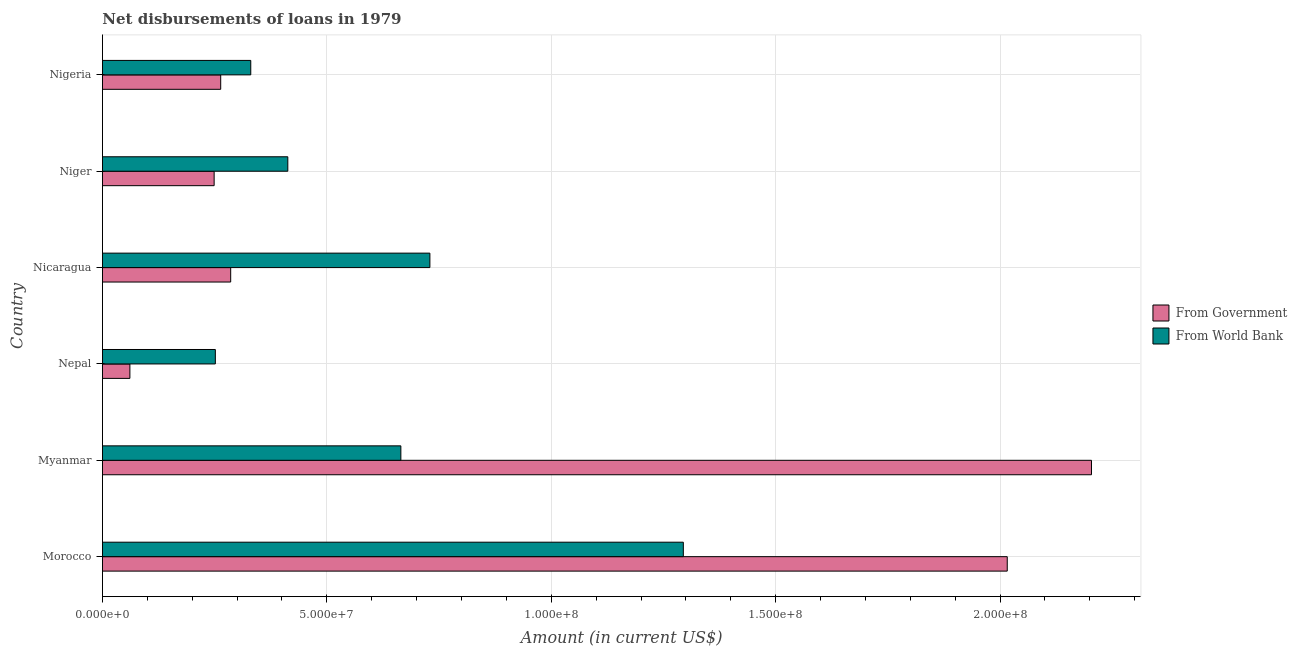How many different coloured bars are there?
Your response must be concise. 2. How many groups of bars are there?
Give a very brief answer. 6. How many bars are there on the 6th tick from the bottom?
Make the answer very short. 2. What is the label of the 3rd group of bars from the top?
Ensure brevity in your answer.  Nicaragua. In how many cases, is the number of bars for a given country not equal to the number of legend labels?
Give a very brief answer. 0. What is the net disbursements of loan from world bank in Niger?
Your response must be concise. 4.13e+07. Across all countries, what is the maximum net disbursements of loan from world bank?
Provide a short and direct response. 1.29e+08. Across all countries, what is the minimum net disbursements of loan from government?
Your answer should be compact. 6.11e+06. In which country was the net disbursements of loan from world bank maximum?
Ensure brevity in your answer.  Morocco. In which country was the net disbursements of loan from government minimum?
Offer a terse response. Nepal. What is the total net disbursements of loan from government in the graph?
Your answer should be very brief. 5.08e+08. What is the difference between the net disbursements of loan from world bank in Morocco and that in Myanmar?
Keep it short and to the point. 6.29e+07. What is the difference between the net disbursements of loan from world bank in Morocco and the net disbursements of loan from government in Nepal?
Offer a terse response. 1.23e+08. What is the average net disbursements of loan from world bank per country?
Provide a succinct answer. 6.14e+07. What is the difference between the net disbursements of loan from world bank and net disbursements of loan from government in Nepal?
Your answer should be very brief. 1.90e+07. What is the ratio of the net disbursements of loan from world bank in Nepal to that in Niger?
Your answer should be very brief. 0.61. Is the difference between the net disbursements of loan from government in Morocco and Nepal greater than the difference between the net disbursements of loan from world bank in Morocco and Nepal?
Make the answer very short. Yes. What is the difference between the highest and the second highest net disbursements of loan from government?
Make the answer very short. 1.88e+07. What is the difference between the highest and the lowest net disbursements of loan from government?
Keep it short and to the point. 2.14e+08. In how many countries, is the net disbursements of loan from world bank greater than the average net disbursements of loan from world bank taken over all countries?
Provide a short and direct response. 3. What does the 1st bar from the top in Morocco represents?
Offer a very short reply. From World Bank. What does the 1st bar from the bottom in Nepal represents?
Make the answer very short. From Government. What is the difference between two consecutive major ticks on the X-axis?
Give a very brief answer. 5.00e+07. What is the title of the graph?
Make the answer very short. Net disbursements of loans in 1979. Does "Age 15+" appear as one of the legend labels in the graph?
Offer a very short reply. No. What is the label or title of the X-axis?
Make the answer very short. Amount (in current US$). What is the label or title of the Y-axis?
Offer a very short reply. Country. What is the Amount (in current US$) of From Government in Morocco?
Provide a short and direct response. 2.02e+08. What is the Amount (in current US$) in From World Bank in Morocco?
Offer a very short reply. 1.29e+08. What is the Amount (in current US$) in From Government in Myanmar?
Provide a succinct answer. 2.20e+08. What is the Amount (in current US$) in From World Bank in Myanmar?
Your response must be concise. 6.65e+07. What is the Amount (in current US$) in From Government in Nepal?
Make the answer very short. 6.11e+06. What is the Amount (in current US$) of From World Bank in Nepal?
Offer a terse response. 2.52e+07. What is the Amount (in current US$) in From Government in Nicaragua?
Provide a short and direct response. 2.86e+07. What is the Amount (in current US$) in From World Bank in Nicaragua?
Offer a terse response. 7.30e+07. What is the Amount (in current US$) of From Government in Niger?
Provide a short and direct response. 2.49e+07. What is the Amount (in current US$) in From World Bank in Niger?
Your answer should be very brief. 4.13e+07. What is the Amount (in current US$) of From Government in Nigeria?
Your answer should be very brief. 2.63e+07. What is the Amount (in current US$) in From World Bank in Nigeria?
Your answer should be very brief. 3.30e+07. Across all countries, what is the maximum Amount (in current US$) in From Government?
Your answer should be compact. 2.20e+08. Across all countries, what is the maximum Amount (in current US$) of From World Bank?
Keep it short and to the point. 1.29e+08. Across all countries, what is the minimum Amount (in current US$) of From Government?
Make the answer very short. 6.11e+06. Across all countries, what is the minimum Amount (in current US$) in From World Bank?
Your response must be concise. 2.52e+07. What is the total Amount (in current US$) in From Government in the graph?
Offer a terse response. 5.08e+08. What is the total Amount (in current US$) of From World Bank in the graph?
Keep it short and to the point. 3.68e+08. What is the difference between the Amount (in current US$) of From Government in Morocco and that in Myanmar?
Keep it short and to the point. -1.88e+07. What is the difference between the Amount (in current US$) in From World Bank in Morocco and that in Myanmar?
Offer a very short reply. 6.29e+07. What is the difference between the Amount (in current US$) of From Government in Morocco and that in Nepal?
Provide a succinct answer. 1.95e+08. What is the difference between the Amount (in current US$) of From World Bank in Morocco and that in Nepal?
Your answer should be very brief. 1.04e+08. What is the difference between the Amount (in current US$) in From Government in Morocco and that in Nicaragua?
Make the answer very short. 1.73e+08. What is the difference between the Amount (in current US$) in From World Bank in Morocco and that in Nicaragua?
Your answer should be compact. 5.65e+07. What is the difference between the Amount (in current US$) of From Government in Morocco and that in Niger?
Keep it short and to the point. 1.77e+08. What is the difference between the Amount (in current US$) of From World Bank in Morocco and that in Niger?
Your response must be concise. 8.81e+07. What is the difference between the Amount (in current US$) in From Government in Morocco and that in Nigeria?
Keep it short and to the point. 1.75e+08. What is the difference between the Amount (in current US$) in From World Bank in Morocco and that in Nigeria?
Keep it short and to the point. 9.64e+07. What is the difference between the Amount (in current US$) in From Government in Myanmar and that in Nepal?
Offer a terse response. 2.14e+08. What is the difference between the Amount (in current US$) of From World Bank in Myanmar and that in Nepal?
Provide a short and direct response. 4.13e+07. What is the difference between the Amount (in current US$) in From Government in Myanmar and that in Nicaragua?
Offer a terse response. 1.92e+08. What is the difference between the Amount (in current US$) in From World Bank in Myanmar and that in Nicaragua?
Offer a terse response. -6.47e+06. What is the difference between the Amount (in current US$) in From Government in Myanmar and that in Niger?
Make the answer very short. 1.95e+08. What is the difference between the Amount (in current US$) of From World Bank in Myanmar and that in Niger?
Your response must be concise. 2.52e+07. What is the difference between the Amount (in current US$) of From Government in Myanmar and that in Nigeria?
Keep it short and to the point. 1.94e+08. What is the difference between the Amount (in current US$) in From World Bank in Myanmar and that in Nigeria?
Offer a very short reply. 3.34e+07. What is the difference between the Amount (in current US$) in From Government in Nepal and that in Nicaragua?
Ensure brevity in your answer.  -2.25e+07. What is the difference between the Amount (in current US$) of From World Bank in Nepal and that in Nicaragua?
Offer a very short reply. -4.78e+07. What is the difference between the Amount (in current US$) in From Government in Nepal and that in Niger?
Ensure brevity in your answer.  -1.88e+07. What is the difference between the Amount (in current US$) in From World Bank in Nepal and that in Niger?
Offer a very short reply. -1.61e+07. What is the difference between the Amount (in current US$) of From Government in Nepal and that in Nigeria?
Make the answer very short. -2.02e+07. What is the difference between the Amount (in current US$) in From World Bank in Nepal and that in Nigeria?
Offer a very short reply. -7.90e+06. What is the difference between the Amount (in current US$) of From Government in Nicaragua and that in Niger?
Make the answer very short. 3.69e+06. What is the difference between the Amount (in current US$) of From World Bank in Nicaragua and that in Niger?
Your response must be concise. 3.17e+07. What is the difference between the Amount (in current US$) of From Government in Nicaragua and that in Nigeria?
Your answer should be compact. 2.22e+06. What is the difference between the Amount (in current US$) in From World Bank in Nicaragua and that in Nigeria?
Your answer should be very brief. 3.99e+07. What is the difference between the Amount (in current US$) of From Government in Niger and that in Nigeria?
Your answer should be compact. -1.46e+06. What is the difference between the Amount (in current US$) of From World Bank in Niger and that in Nigeria?
Keep it short and to the point. 8.25e+06. What is the difference between the Amount (in current US$) of From Government in Morocco and the Amount (in current US$) of From World Bank in Myanmar?
Your answer should be compact. 1.35e+08. What is the difference between the Amount (in current US$) in From Government in Morocco and the Amount (in current US$) in From World Bank in Nepal?
Provide a short and direct response. 1.76e+08. What is the difference between the Amount (in current US$) in From Government in Morocco and the Amount (in current US$) in From World Bank in Nicaragua?
Your response must be concise. 1.29e+08. What is the difference between the Amount (in current US$) in From Government in Morocco and the Amount (in current US$) in From World Bank in Niger?
Make the answer very short. 1.60e+08. What is the difference between the Amount (in current US$) in From Government in Morocco and the Amount (in current US$) in From World Bank in Nigeria?
Make the answer very short. 1.69e+08. What is the difference between the Amount (in current US$) of From Government in Myanmar and the Amount (in current US$) of From World Bank in Nepal?
Provide a succinct answer. 1.95e+08. What is the difference between the Amount (in current US$) in From Government in Myanmar and the Amount (in current US$) in From World Bank in Nicaragua?
Provide a short and direct response. 1.47e+08. What is the difference between the Amount (in current US$) in From Government in Myanmar and the Amount (in current US$) in From World Bank in Niger?
Provide a short and direct response. 1.79e+08. What is the difference between the Amount (in current US$) in From Government in Myanmar and the Amount (in current US$) in From World Bank in Nigeria?
Provide a short and direct response. 1.87e+08. What is the difference between the Amount (in current US$) in From Government in Nepal and the Amount (in current US$) in From World Bank in Nicaragua?
Make the answer very short. -6.68e+07. What is the difference between the Amount (in current US$) of From Government in Nepal and the Amount (in current US$) of From World Bank in Niger?
Ensure brevity in your answer.  -3.52e+07. What is the difference between the Amount (in current US$) in From Government in Nepal and the Amount (in current US$) in From World Bank in Nigeria?
Offer a terse response. -2.69e+07. What is the difference between the Amount (in current US$) in From Government in Nicaragua and the Amount (in current US$) in From World Bank in Niger?
Offer a terse response. -1.27e+07. What is the difference between the Amount (in current US$) of From Government in Nicaragua and the Amount (in current US$) of From World Bank in Nigeria?
Your answer should be compact. -4.48e+06. What is the difference between the Amount (in current US$) of From Government in Niger and the Amount (in current US$) of From World Bank in Nigeria?
Offer a very short reply. -8.16e+06. What is the average Amount (in current US$) in From Government per country?
Provide a succinct answer. 8.46e+07. What is the average Amount (in current US$) of From World Bank per country?
Ensure brevity in your answer.  6.14e+07. What is the difference between the Amount (in current US$) in From Government and Amount (in current US$) in From World Bank in Morocco?
Ensure brevity in your answer.  7.22e+07. What is the difference between the Amount (in current US$) of From Government and Amount (in current US$) of From World Bank in Myanmar?
Your answer should be compact. 1.54e+08. What is the difference between the Amount (in current US$) in From Government and Amount (in current US$) in From World Bank in Nepal?
Offer a very short reply. -1.90e+07. What is the difference between the Amount (in current US$) of From Government and Amount (in current US$) of From World Bank in Nicaragua?
Your answer should be compact. -4.44e+07. What is the difference between the Amount (in current US$) of From Government and Amount (in current US$) of From World Bank in Niger?
Ensure brevity in your answer.  -1.64e+07. What is the difference between the Amount (in current US$) in From Government and Amount (in current US$) in From World Bank in Nigeria?
Your answer should be compact. -6.70e+06. What is the ratio of the Amount (in current US$) of From Government in Morocco to that in Myanmar?
Offer a terse response. 0.91. What is the ratio of the Amount (in current US$) of From World Bank in Morocco to that in Myanmar?
Provide a succinct answer. 1.95. What is the ratio of the Amount (in current US$) of From Government in Morocco to that in Nepal?
Provide a succinct answer. 32.99. What is the ratio of the Amount (in current US$) in From World Bank in Morocco to that in Nepal?
Your answer should be compact. 5.15. What is the ratio of the Amount (in current US$) in From Government in Morocco to that in Nicaragua?
Ensure brevity in your answer.  7.06. What is the ratio of the Amount (in current US$) of From World Bank in Morocco to that in Nicaragua?
Your answer should be very brief. 1.77. What is the ratio of the Amount (in current US$) of From Government in Morocco to that in Niger?
Offer a very short reply. 8.1. What is the ratio of the Amount (in current US$) of From World Bank in Morocco to that in Niger?
Provide a short and direct response. 3.13. What is the ratio of the Amount (in current US$) of From Government in Morocco to that in Nigeria?
Your answer should be very brief. 7.65. What is the ratio of the Amount (in current US$) of From World Bank in Morocco to that in Nigeria?
Your answer should be very brief. 3.92. What is the ratio of the Amount (in current US$) of From Government in Myanmar to that in Nepal?
Your response must be concise. 36.06. What is the ratio of the Amount (in current US$) of From World Bank in Myanmar to that in Nepal?
Your answer should be compact. 2.64. What is the ratio of the Amount (in current US$) in From Government in Myanmar to that in Nicaragua?
Provide a succinct answer. 7.71. What is the ratio of the Amount (in current US$) in From World Bank in Myanmar to that in Nicaragua?
Keep it short and to the point. 0.91. What is the ratio of the Amount (in current US$) of From Government in Myanmar to that in Niger?
Your answer should be compact. 8.86. What is the ratio of the Amount (in current US$) of From World Bank in Myanmar to that in Niger?
Keep it short and to the point. 1.61. What is the ratio of the Amount (in current US$) of From Government in Myanmar to that in Nigeria?
Offer a very short reply. 8.36. What is the ratio of the Amount (in current US$) of From World Bank in Myanmar to that in Nigeria?
Make the answer very short. 2.01. What is the ratio of the Amount (in current US$) of From Government in Nepal to that in Nicaragua?
Make the answer very short. 0.21. What is the ratio of the Amount (in current US$) of From World Bank in Nepal to that in Nicaragua?
Your answer should be very brief. 0.34. What is the ratio of the Amount (in current US$) of From Government in Nepal to that in Niger?
Make the answer very short. 0.25. What is the ratio of the Amount (in current US$) in From World Bank in Nepal to that in Niger?
Keep it short and to the point. 0.61. What is the ratio of the Amount (in current US$) in From Government in Nepal to that in Nigeria?
Keep it short and to the point. 0.23. What is the ratio of the Amount (in current US$) of From World Bank in Nepal to that in Nigeria?
Give a very brief answer. 0.76. What is the ratio of the Amount (in current US$) in From Government in Nicaragua to that in Niger?
Ensure brevity in your answer.  1.15. What is the ratio of the Amount (in current US$) of From World Bank in Nicaragua to that in Niger?
Your response must be concise. 1.77. What is the ratio of the Amount (in current US$) of From Government in Nicaragua to that in Nigeria?
Give a very brief answer. 1.08. What is the ratio of the Amount (in current US$) in From World Bank in Nicaragua to that in Nigeria?
Your response must be concise. 2.21. What is the ratio of the Amount (in current US$) in From Government in Niger to that in Nigeria?
Provide a short and direct response. 0.94. What is the ratio of the Amount (in current US$) in From World Bank in Niger to that in Nigeria?
Provide a short and direct response. 1.25. What is the difference between the highest and the second highest Amount (in current US$) in From Government?
Offer a terse response. 1.88e+07. What is the difference between the highest and the second highest Amount (in current US$) in From World Bank?
Make the answer very short. 5.65e+07. What is the difference between the highest and the lowest Amount (in current US$) in From Government?
Provide a succinct answer. 2.14e+08. What is the difference between the highest and the lowest Amount (in current US$) in From World Bank?
Your answer should be very brief. 1.04e+08. 